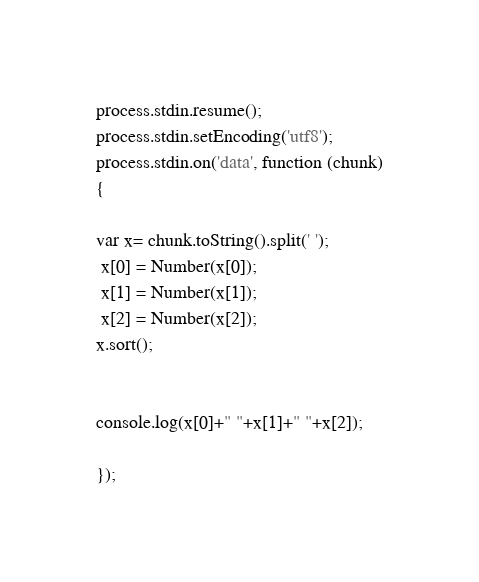Convert code to text. <code><loc_0><loc_0><loc_500><loc_500><_JavaScript_>process.stdin.resume();
process.stdin.setEncoding('utf8');
process.stdin.on('data', function (chunk)
{

var x= chunk.toString().split(' ');
 x[0] = Number(x[0]);
 x[1] = Number(x[1]);
 x[2] = Number(x[2]);
x.sort();


console.log(x[0]+" "+x[1]+" "+x[2]);

});</code> 